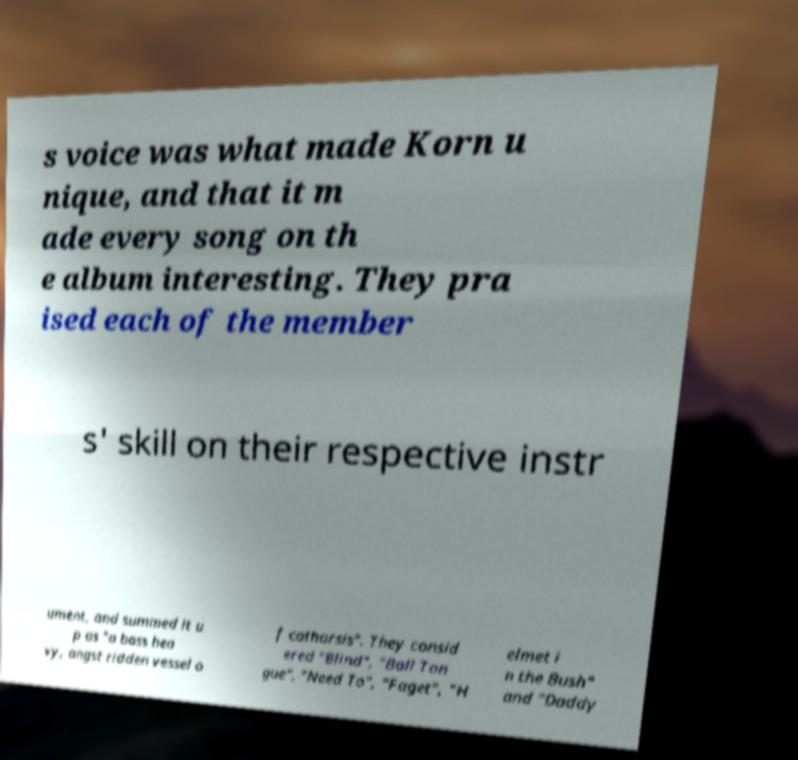For documentation purposes, I need the text within this image transcribed. Could you provide that? s voice was what made Korn u nique, and that it m ade every song on th e album interesting. They pra ised each of the member s' skill on their respective instr ument, and summed it u p as "a bass hea vy, angst ridden vessel o f catharsis". They consid ered "Blind", "Ball Ton gue", "Need To", "Faget", "H elmet i n the Bush" and "Daddy 